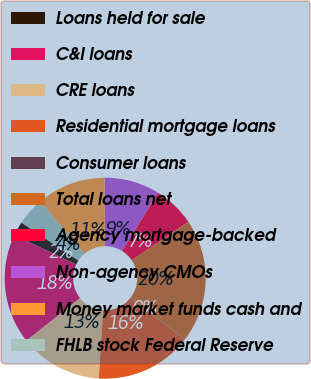Convert chart. <chart><loc_0><loc_0><loc_500><loc_500><pie_chart><fcel>Loans held for sale<fcel>C&I loans<fcel>CRE loans<fcel>Residential mortgage loans<fcel>Consumer loans<fcel>Total loans net<fcel>Agency mortgage-backed<fcel>Non-agency CMOs<fcel>Money market funds cash and<fcel>FHLB stock Federal Reserve<nl><fcel>2.27%<fcel>17.73%<fcel>13.31%<fcel>15.52%<fcel>0.06%<fcel>19.94%<fcel>6.69%<fcel>8.9%<fcel>11.1%<fcel>4.48%<nl></chart> 